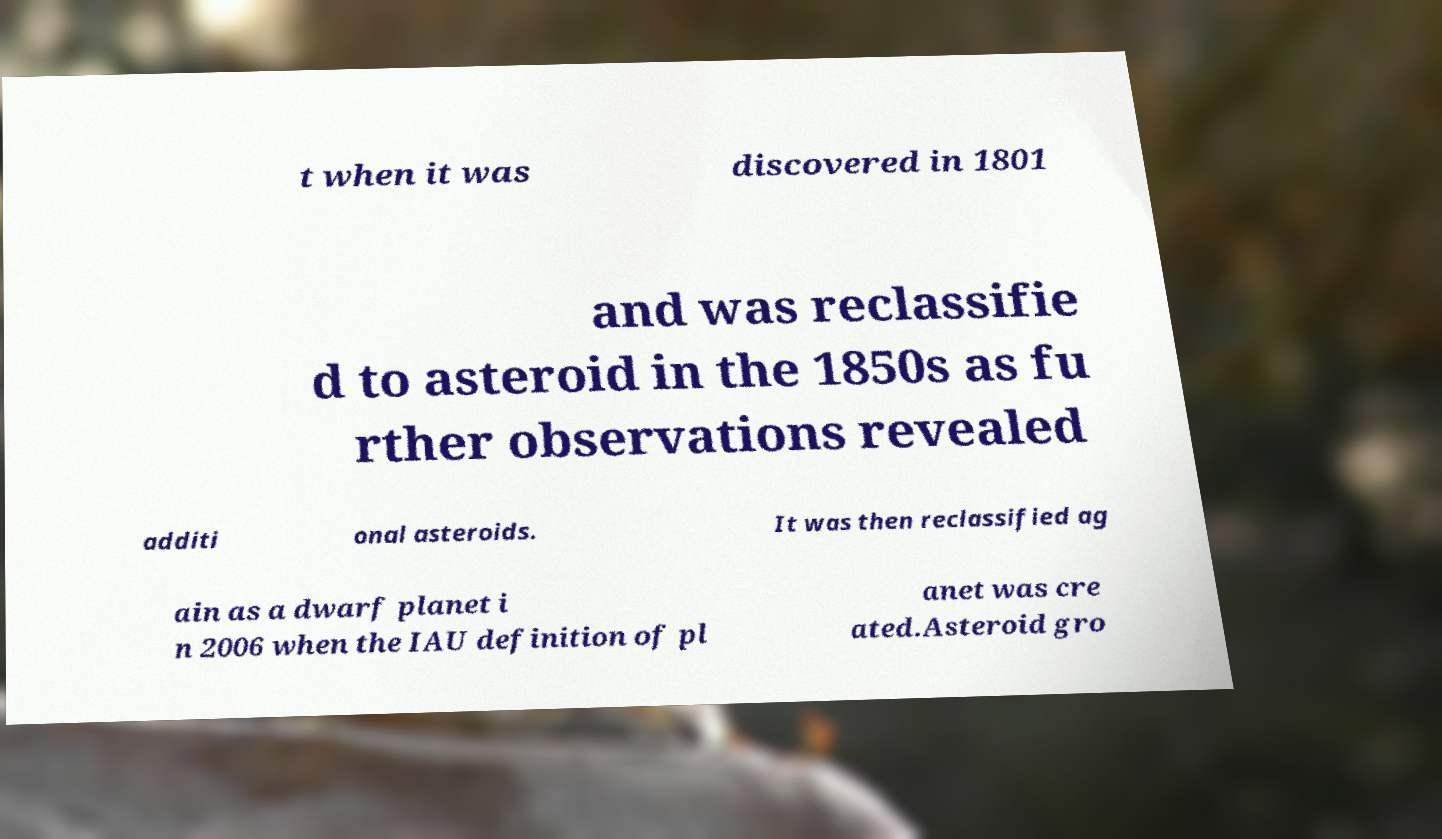Please identify and transcribe the text found in this image. t when it was discovered in 1801 and was reclassifie d to asteroid in the 1850s as fu rther observations revealed additi onal asteroids. It was then reclassified ag ain as a dwarf planet i n 2006 when the IAU definition of pl anet was cre ated.Asteroid gro 